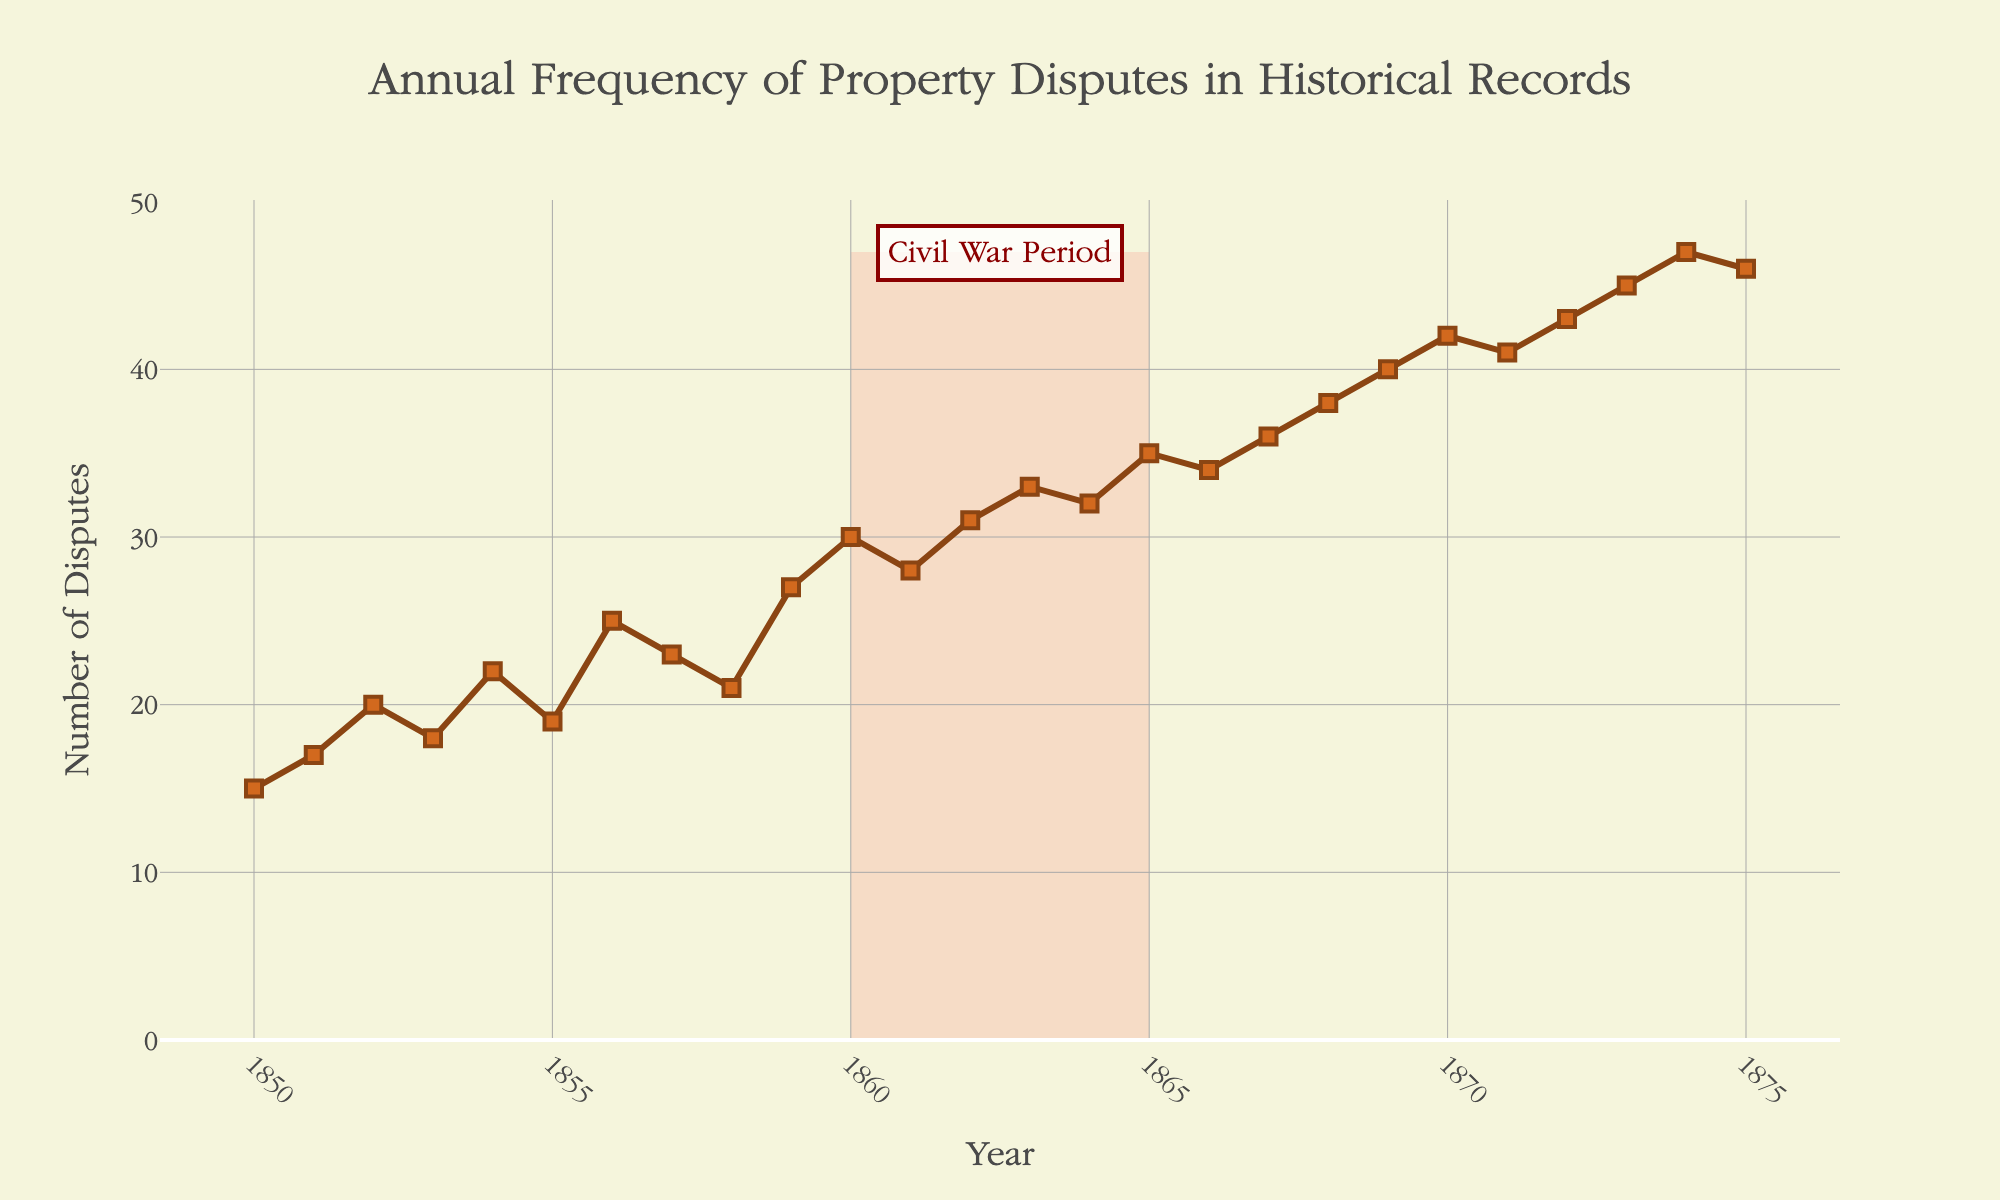What is the title of the figure? The title is located at the top center of the figure. It reads "Annual Frequency of Property Disputes in Historical Records".
Answer: Annual Frequency of Property Disputes in Historical Records What is the y-axis labeled as? The y-axis label can be found on the left side of the figure. It reads "Number of Disputes".
Answer: Number of Disputes How many data points are displayed in the figure? Each point on the graph corresponds to a year with its respective number of disputes. Counting these gives us a total of 26 data points.
Answer: 26 What time period does the highlighted rectangle represent? The highlighted rectangle covers the years from 1860 to 1865. This is explicitly marked on the figure with a red shaded area and an annotation.
Answer: 1860 to 1865 What is the trend in the number of property disputes from 1850 to 1875? The trend can be seen by observing the line connecting the data points. It shows an overall increasing trend in the number of property disputes over this period.
Answer: Increasing trend Which year has the highest number of property disputes? By looking at the y-values of the plotted points, the year 1874 has the highest count at 47 disputes.
Answer: 1874 What was the number of disputes for the year 1865? The point corresponding to the year 1865 on the x-axis shows the y-value of 35 disputes.
Answer: 35 Compare the number of disputes in 1860 and 1865. Which year had more disputes? Checking the data points for 1860 and 1865, 1860 had 30 disputes while 1865 had 35. Therefore, 1865 had more disputes.
Answer: 1865 What is the average number of disputes from 1850 to 1855? Adding the disputes from 1850 to 1855 (15, 17, 20, 18, 22, 19) gives a total of 111. Dividing by 6 years, the average is 18.5 disputes per year.
Answer: 18.5 How does the number of disputes change during the highlighted period? The highlighted period (1860-1865) shows an increase from 30 disputes in 1860 to 35 disputes in 1865.
Answer: Increase 